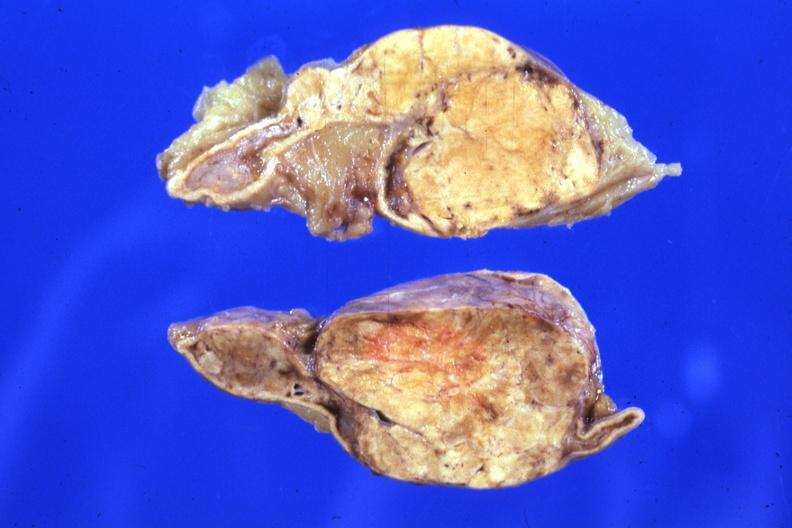what is fixed tissue sectioned?
Answer the question using a single word or phrase. Gland rather large lesion 